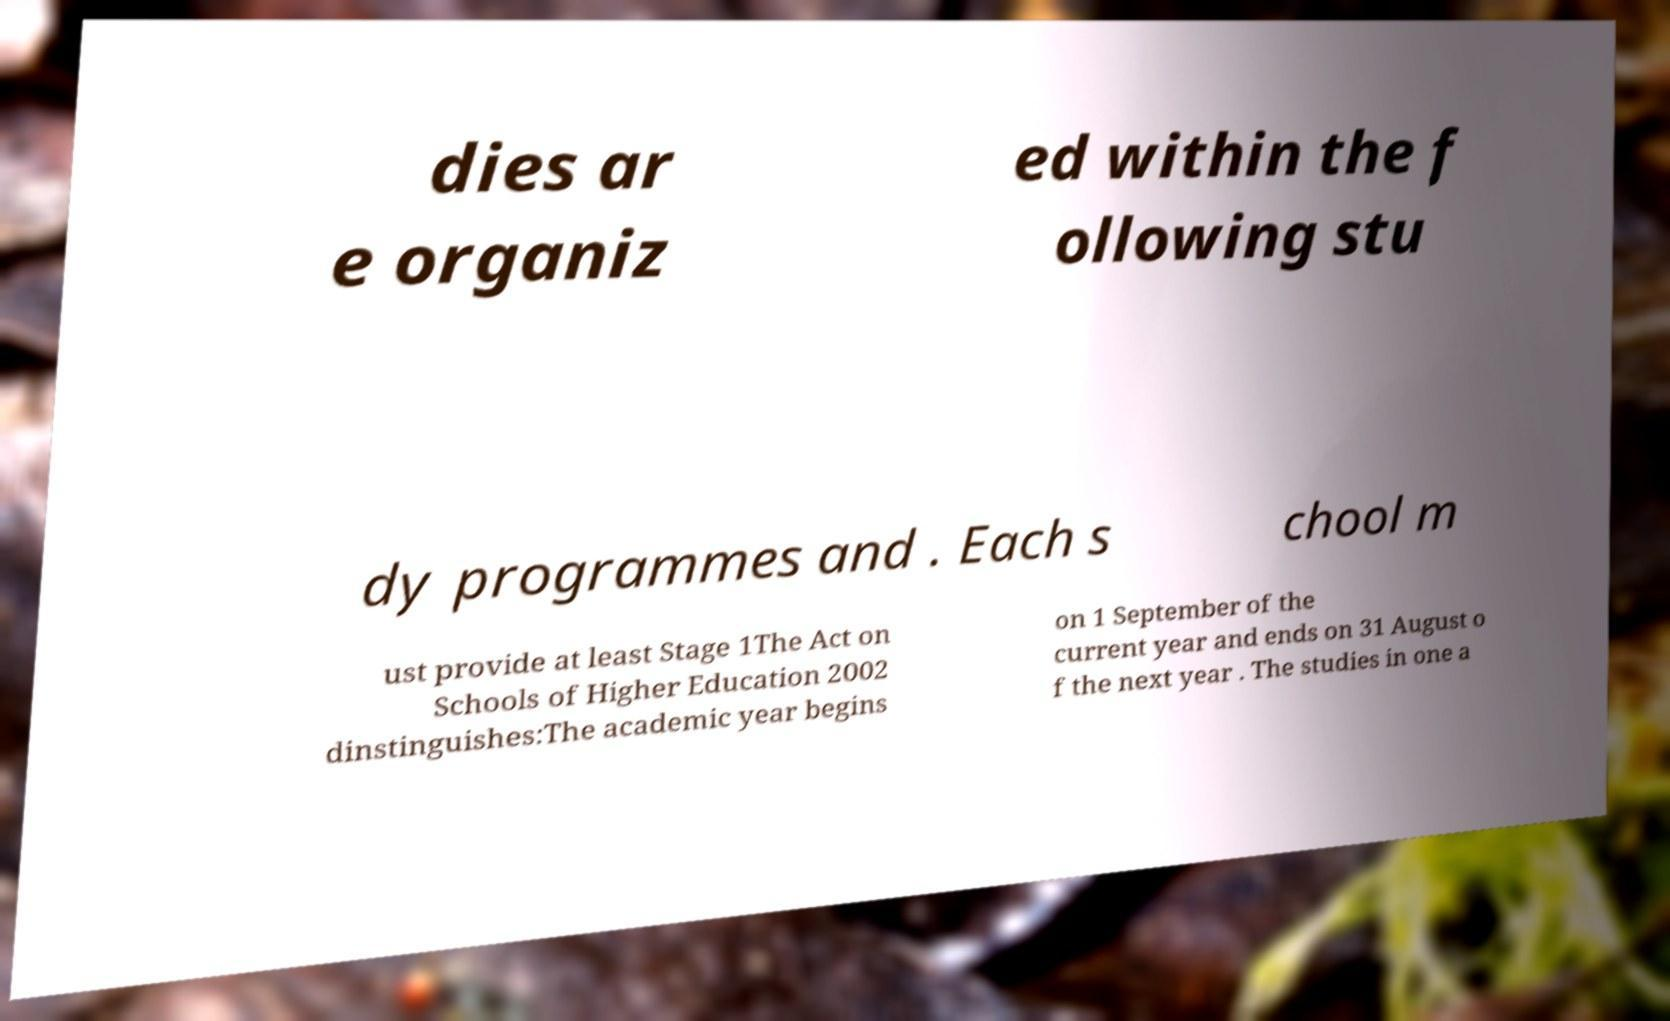Please identify and transcribe the text found in this image. dies ar e organiz ed within the f ollowing stu dy programmes and . Each s chool m ust provide at least Stage 1The Act on Schools of Higher Education 2002 dinstinguishes:The academic year begins on 1 September of the current year and ends on 31 August o f the next year . The studies in one a 